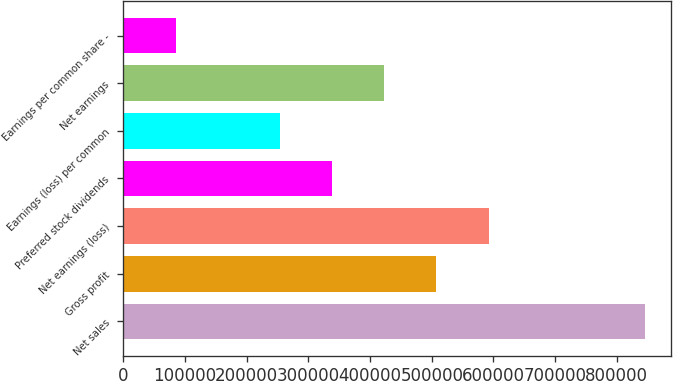Convert chart. <chart><loc_0><loc_0><loc_500><loc_500><bar_chart><fcel>Net sales<fcel>Gross profit<fcel>Net earnings (loss)<fcel>Preferred stock dividends<fcel>Earnings (loss) per common<fcel>Net earnings<fcel>Earnings per common share -<nl><fcel>846071<fcel>507643<fcel>592250<fcel>338429<fcel>253822<fcel>423036<fcel>84607.4<nl></chart> 